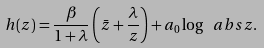Convert formula to latex. <formula><loc_0><loc_0><loc_500><loc_500>h ( z ) = \frac { \beta } { 1 + \lambda } \left ( \bar { z } + \frac { \lambda } { z } \right ) + a _ { 0 } \log \ a b s { z } .</formula> 